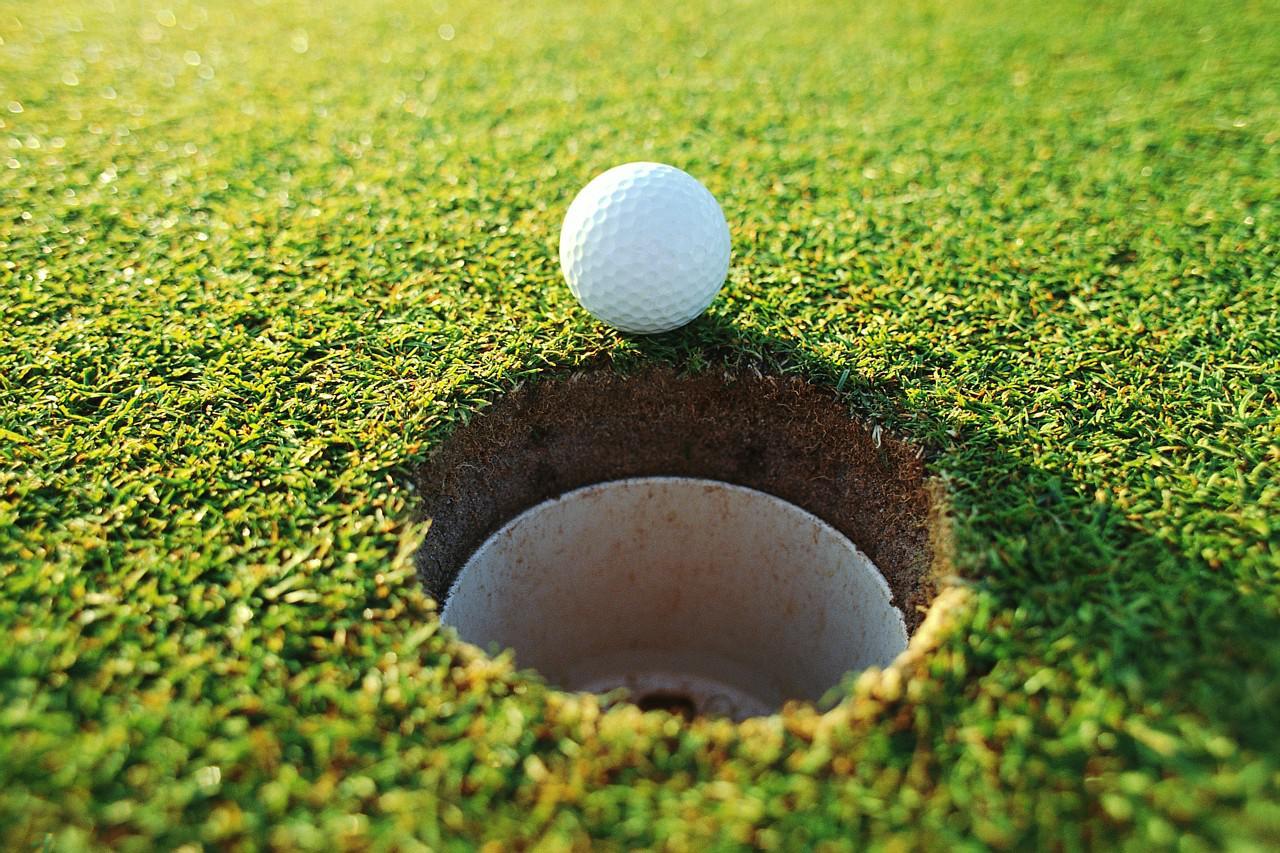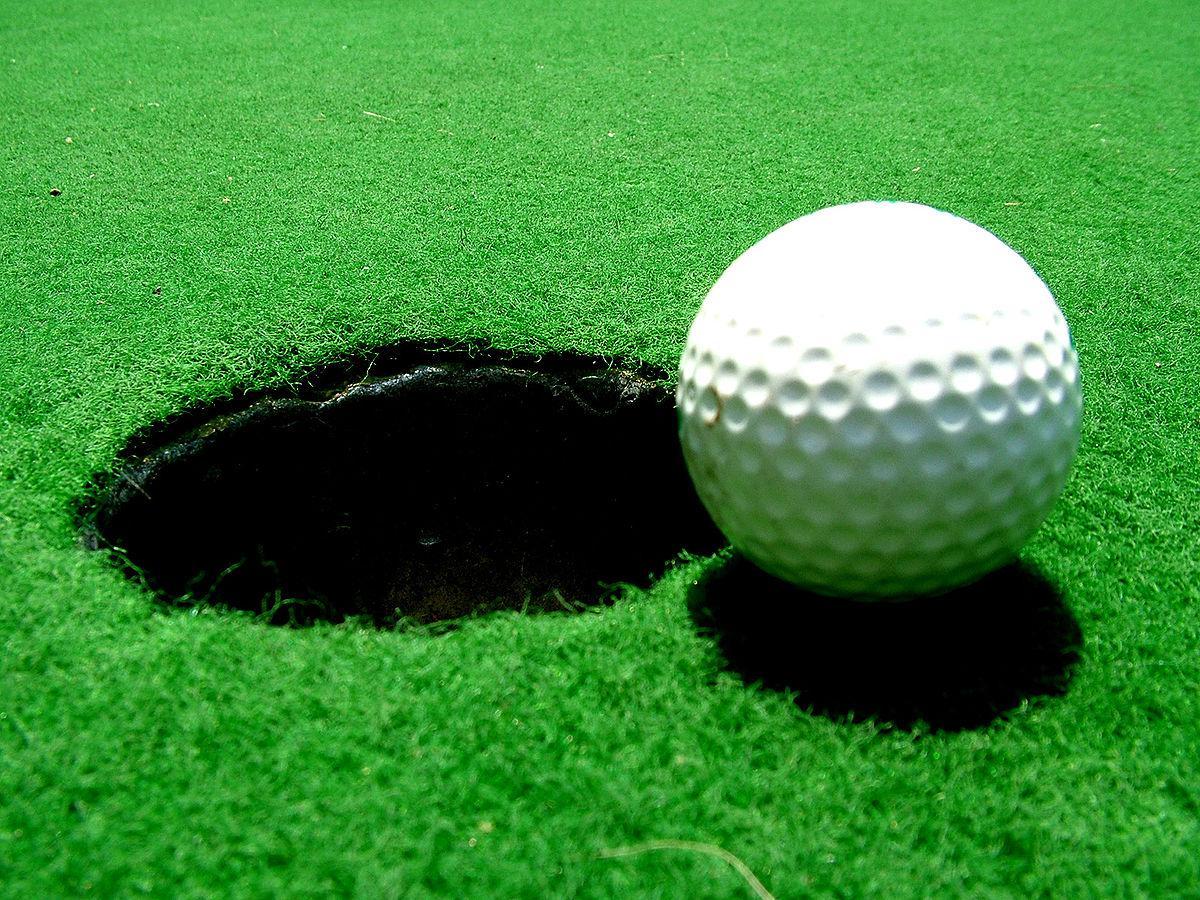The first image is the image on the left, the second image is the image on the right. Examine the images to the left and right. Is the description "In one of the images there is a golf ball on the very edge of a hole that has the flag pole in it." accurate? Answer yes or no. No. The first image is the image on the left, the second image is the image on the right. Given the left and right images, does the statement "One image shows a golf ball at the edge of a hole that has a pole in it, but not inside the hole." hold true? Answer yes or no. No. 